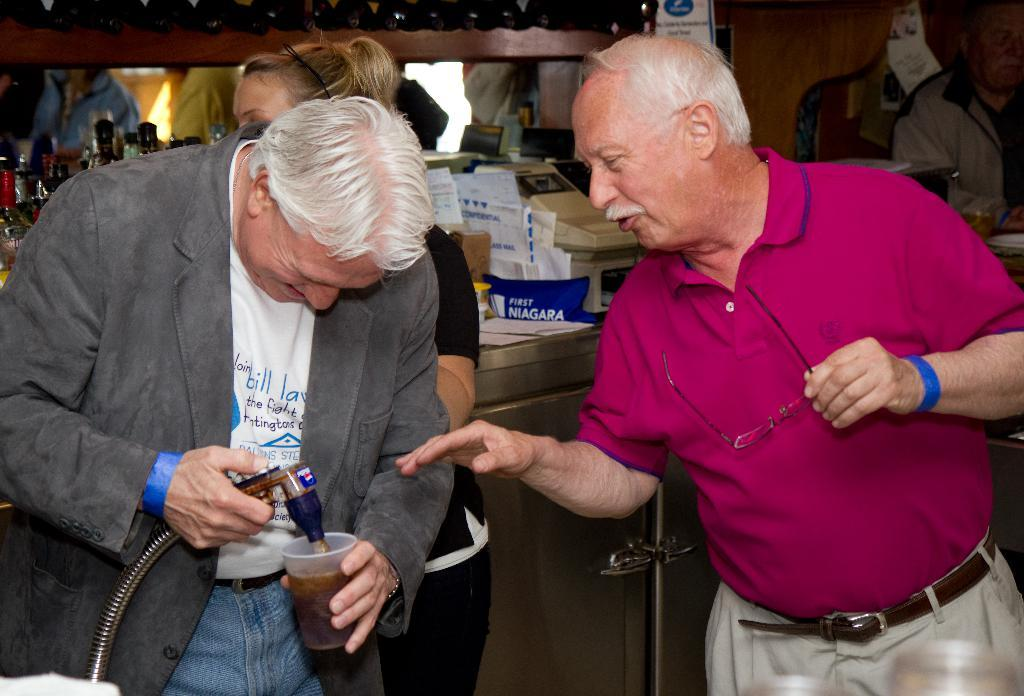Who or what is present in the image? There are people in the image. What else can be seen in the image besides people? There are papers, devices, posters, objects, and bottles on racks in the image. Can you describe the devices in the image? Unfortunately, the facts provided do not give specific details about the devices in the image. What type of objects can be seen in the image? The facts provided do not specify the type of objects in the image, but we know there are objects present. How many drops of water can be seen falling from the sea in the image? There is no sea or water drops present in the image. 